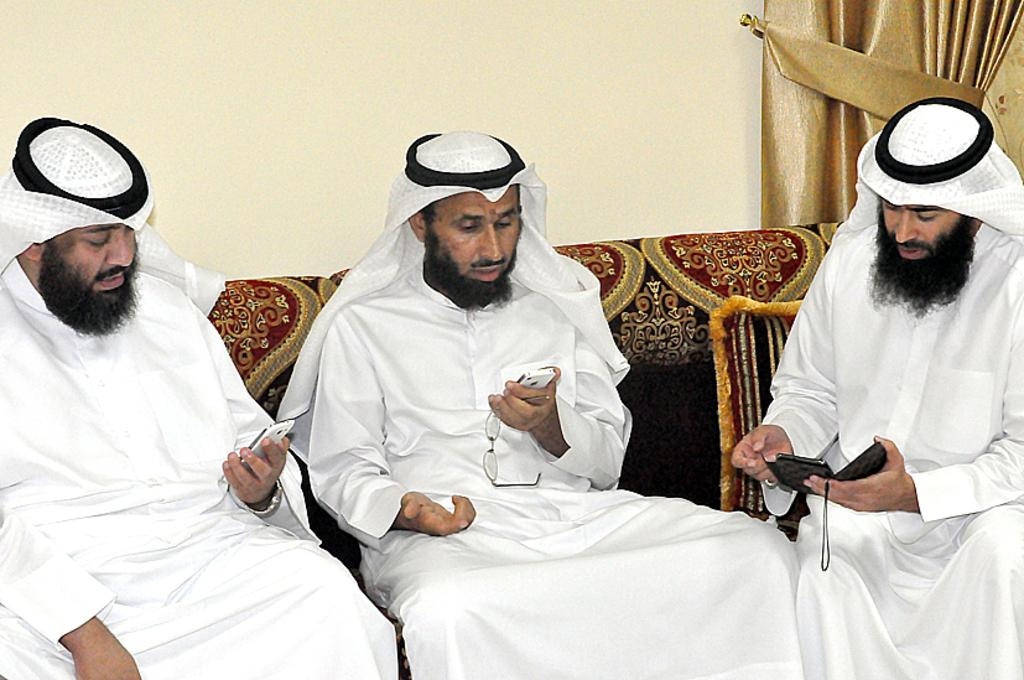What are the people in the image doing? The people in the image are sitting on the sofa. What type of clothing are the people wearing? The people are wearing kurtas and turbans. What are the people holding in their hands? The people are holding objects. What can be seen in the background of the image? There is a curtain and a wall in the background of the image. What shape is the butter on the table in the image? There is no butter present in the image. What type of roof can be seen in the image? There is no roof visible in the image; it only shows people sitting on a sofa with a background of a curtain and a wall. 